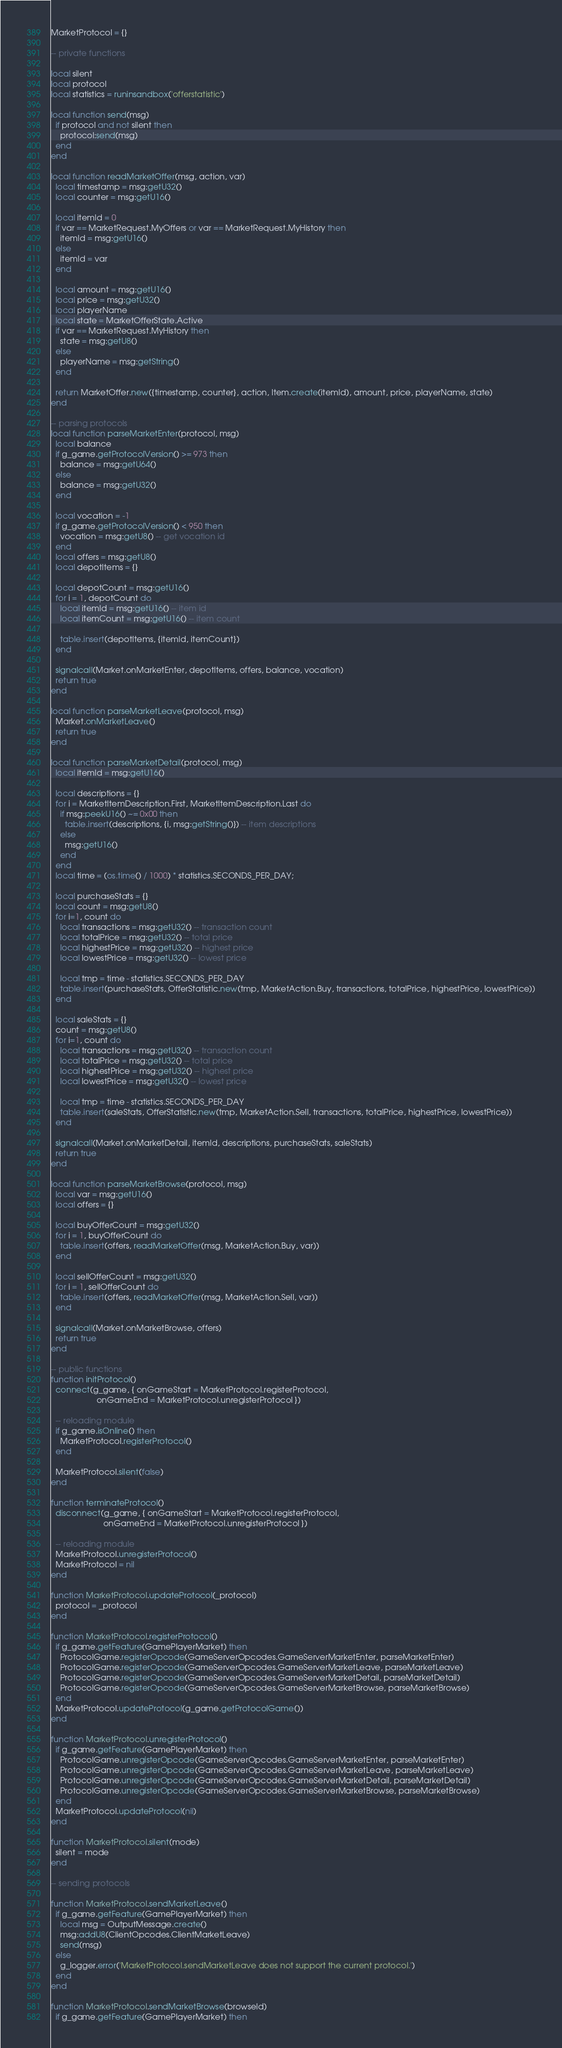<code> <loc_0><loc_0><loc_500><loc_500><_Lua_>MarketProtocol = {}

-- private functions

local silent
local protocol
local statistics = runinsandbox('offerstatistic')

local function send(msg)
  if protocol and not silent then
    protocol:send(msg)
  end
end

local function readMarketOffer(msg, action, var)
  local timestamp = msg:getU32()
  local counter = msg:getU16()

  local itemId = 0
  if var == MarketRequest.MyOffers or var == MarketRequest.MyHistory then
    itemId = msg:getU16()
  else
    itemId = var
  end

  local amount = msg:getU16()
  local price = msg:getU32()
  local playerName
  local state = MarketOfferState.Active
  if var == MarketRequest.MyHistory then
    state = msg:getU8()
  else
    playerName = msg:getString()
  end

  return MarketOffer.new({timestamp, counter}, action, Item.create(itemId), amount, price, playerName, state)
end

-- parsing protocols
local function parseMarketEnter(protocol, msg)
  local balance
  if g_game.getProtocolVersion() >= 973 then
    balance = msg:getU64()
  else
    balance = msg:getU32()
  end

  local vocation = -1
  if g_game.getProtocolVersion() < 950 then
    vocation = msg:getU8() -- get vocation id
  end
  local offers = msg:getU8()
  local depotItems = {}

  local depotCount = msg:getU16()
  for i = 1, depotCount do
    local itemId = msg:getU16() -- item id
    local itemCount = msg:getU16() -- item count

    table.insert(depotItems, {itemId, itemCount})
  end

  signalcall(Market.onMarketEnter, depotItems, offers, balance, vocation)
  return true
end

local function parseMarketLeave(protocol, msg)
  Market.onMarketLeave()
  return true
end

local function parseMarketDetail(protocol, msg)
  local itemId = msg:getU16()

  local descriptions = {}
  for i = MarketItemDescription.First, MarketItemDescription.Last do
    if msg:peekU16() ~= 0x00 then
      table.insert(descriptions, {i, msg:getString()}) -- item descriptions
    else
      msg:getU16()
    end
  end
  local time = (os.time() / 1000) * statistics.SECONDS_PER_DAY;

  local purchaseStats = {}
  local count = msg:getU8()
  for i=1, count do
    local transactions = msg:getU32() -- transaction count
    local totalPrice = msg:getU32() -- total price
    local highestPrice = msg:getU32() -- highest price
    local lowestPrice = msg:getU32() -- lowest price

    local tmp = time - statistics.SECONDS_PER_DAY
    table.insert(purchaseStats, OfferStatistic.new(tmp, MarketAction.Buy, transactions, totalPrice, highestPrice, lowestPrice))
  end

  local saleStats = {}
  count = msg:getU8()
  for i=1, count do
    local transactions = msg:getU32() -- transaction count
    local totalPrice = msg:getU32() -- total price
    local highestPrice = msg:getU32() -- highest price
    local lowestPrice = msg:getU32() -- lowest price

    local tmp = time - statistics.SECONDS_PER_DAY
    table.insert(saleStats, OfferStatistic.new(tmp, MarketAction.Sell, transactions, totalPrice, highestPrice, lowestPrice))
  end

  signalcall(Market.onMarketDetail, itemId, descriptions, purchaseStats, saleStats)
  return true
end

local function parseMarketBrowse(protocol, msg)
  local var = msg:getU16()
  local offers = {}

  local buyOfferCount = msg:getU32()
  for i = 1, buyOfferCount do
    table.insert(offers, readMarketOffer(msg, MarketAction.Buy, var))
  end

  local sellOfferCount = msg:getU32()
  for i = 1, sellOfferCount do
    table.insert(offers, readMarketOffer(msg, MarketAction.Sell, var))
  end

  signalcall(Market.onMarketBrowse, offers)
  return true
end

-- public functions
function initProtocol()
  connect(g_game, { onGameStart = MarketProtocol.registerProtocol,
                    onGameEnd = MarketProtocol.unregisterProtocol })

  -- reloading module
  if g_game.isOnline() then
    MarketProtocol.registerProtocol()
  end

  MarketProtocol.silent(false)
end

function terminateProtocol()
  disconnect(g_game, { onGameStart = MarketProtocol.registerProtocol,
                       onGameEnd = MarketProtocol.unregisterProtocol })

  -- reloading module
  MarketProtocol.unregisterProtocol()
  MarketProtocol = nil
end

function MarketProtocol.updateProtocol(_protocol)
  protocol = _protocol
end

function MarketProtocol.registerProtocol()
  if g_game.getFeature(GamePlayerMarket) then
    ProtocolGame.registerOpcode(GameServerOpcodes.GameServerMarketEnter, parseMarketEnter)
    ProtocolGame.registerOpcode(GameServerOpcodes.GameServerMarketLeave, parseMarketLeave)
    ProtocolGame.registerOpcode(GameServerOpcodes.GameServerMarketDetail, parseMarketDetail)
    ProtocolGame.registerOpcode(GameServerOpcodes.GameServerMarketBrowse, parseMarketBrowse)
  end
  MarketProtocol.updateProtocol(g_game.getProtocolGame())
end

function MarketProtocol.unregisterProtocol()
  if g_game.getFeature(GamePlayerMarket) then
    ProtocolGame.unregisterOpcode(GameServerOpcodes.GameServerMarketEnter, parseMarketEnter)
    ProtocolGame.unregisterOpcode(GameServerOpcodes.GameServerMarketLeave, parseMarketLeave)
    ProtocolGame.unregisterOpcode(GameServerOpcodes.GameServerMarketDetail, parseMarketDetail)
    ProtocolGame.unregisterOpcode(GameServerOpcodes.GameServerMarketBrowse, parseMarketBrowse)
  end
  MarketProtocol.updateProtocol(nil)
end

function MarketProtocol.silent(mode)
  silent = mode
end

-- sending protocols

function MarketProtocol.sendMarketLeave()
  if g_game.getFeature(GamePlayerMarket) then
    local msg = OutputMessage.create()
    msg:addU8(ClientOpcodes.ClientMarketLeave)
    send(msg)
  else
    g_logger.error('MarketProtocol.sendMarketLeave does not support the current protocol.')
  end
end

function MarketProtocol.sendMarketBrowse(browseId)
  if g_game.getFeature(GamePlayerMarket) then</code> 